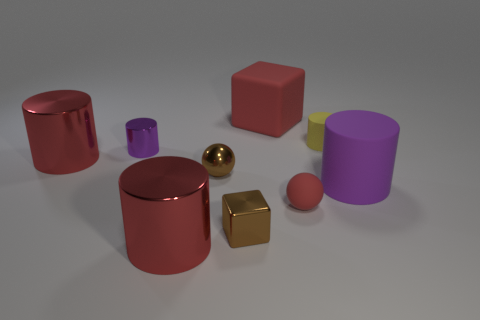What is the size of the shiny cube that is on the right side of the tiny brown metallic ball?
Offer a very short reply. Small. Are there fewer big purple rubber objects in front of the tiny block than big blocks to the left of the big red rubber block?
Make the answer very short. No. What is the color of the matte sphere?
Make the answer very short. Red. Is there a big block of the same color as the small metallic sphere?
Give a very brief answer. No. The big red metallic object that is behind the red rubber thing in front of the tiny cylinder right of the brown metallic ball is what shape?
Offer a very short reply. Cylinder. What is the material of the large red cylinder that is right of the tiny shiny cylinder?
Keep it short and to the point. Metal. There is a purple cylinder that is right of the large red metal object in front of the thing to the right of the yellow rubber cylinder; what size is it?
Give a very brief answer. Large. Do the purple matte cylinder and the metal cylinder that is in front of the tiny brown shiny ball have the same size?
Your answer should be very brief. Yes. What is the color of the large cylinder in front of the brown cube?
Provide a short and direct response. Red. There is a small metallic thing that is the same color as the large rubber cylinder; what is its shape?
Offer a terse response. Cylinder. 